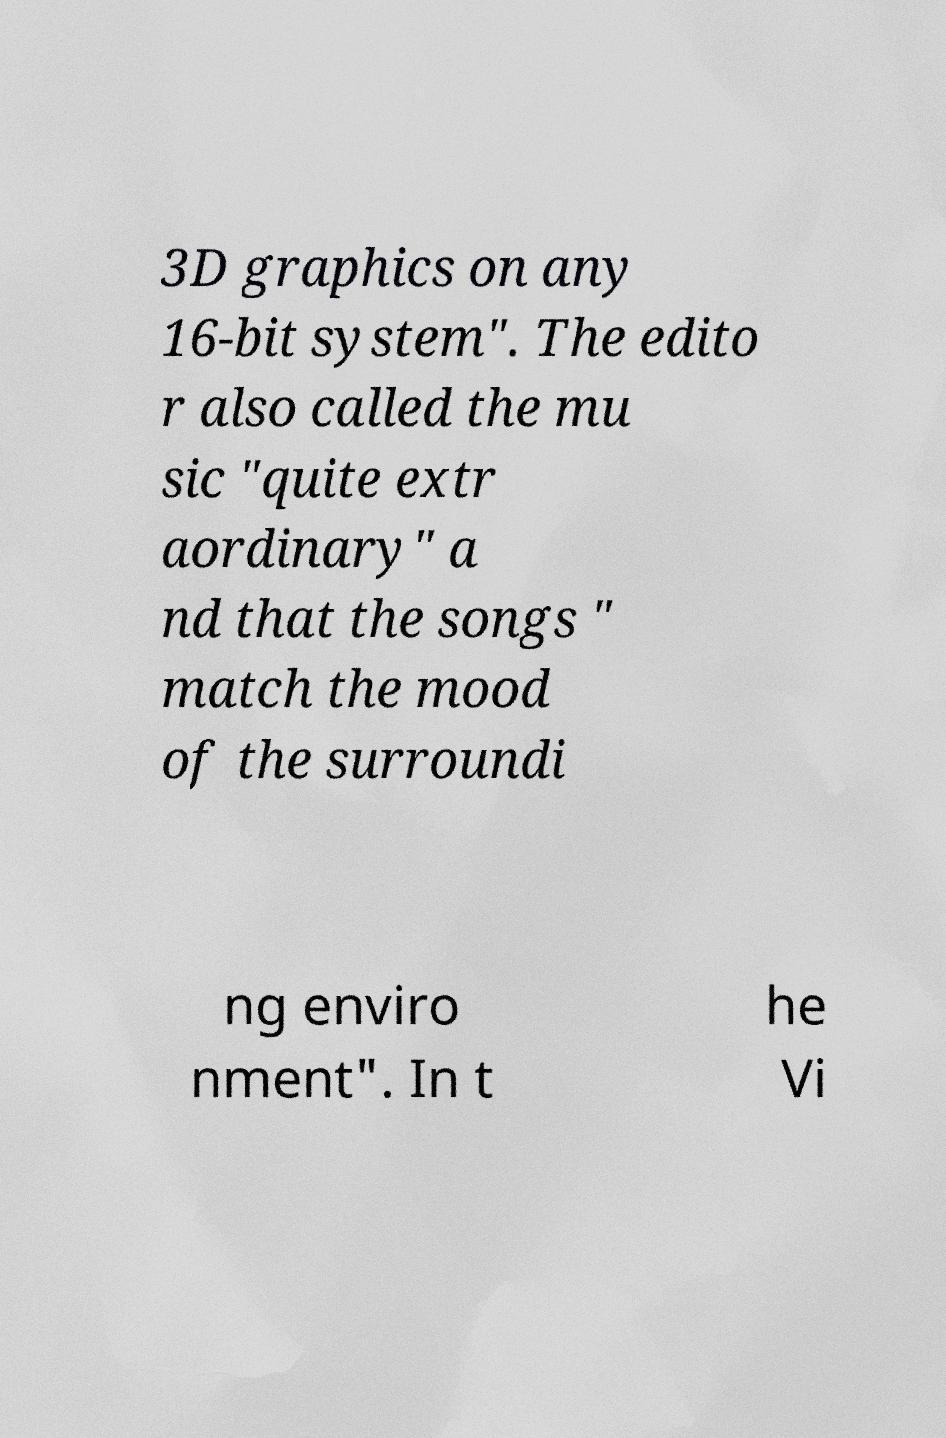Could you extract and type out the text from this image? 3D graphics on any 16-bit system". The edito r also called the mu sic "quite extr aordinary" a nd that the songs " match the mood of the surroundi ng enviro nment". In t he Vi 